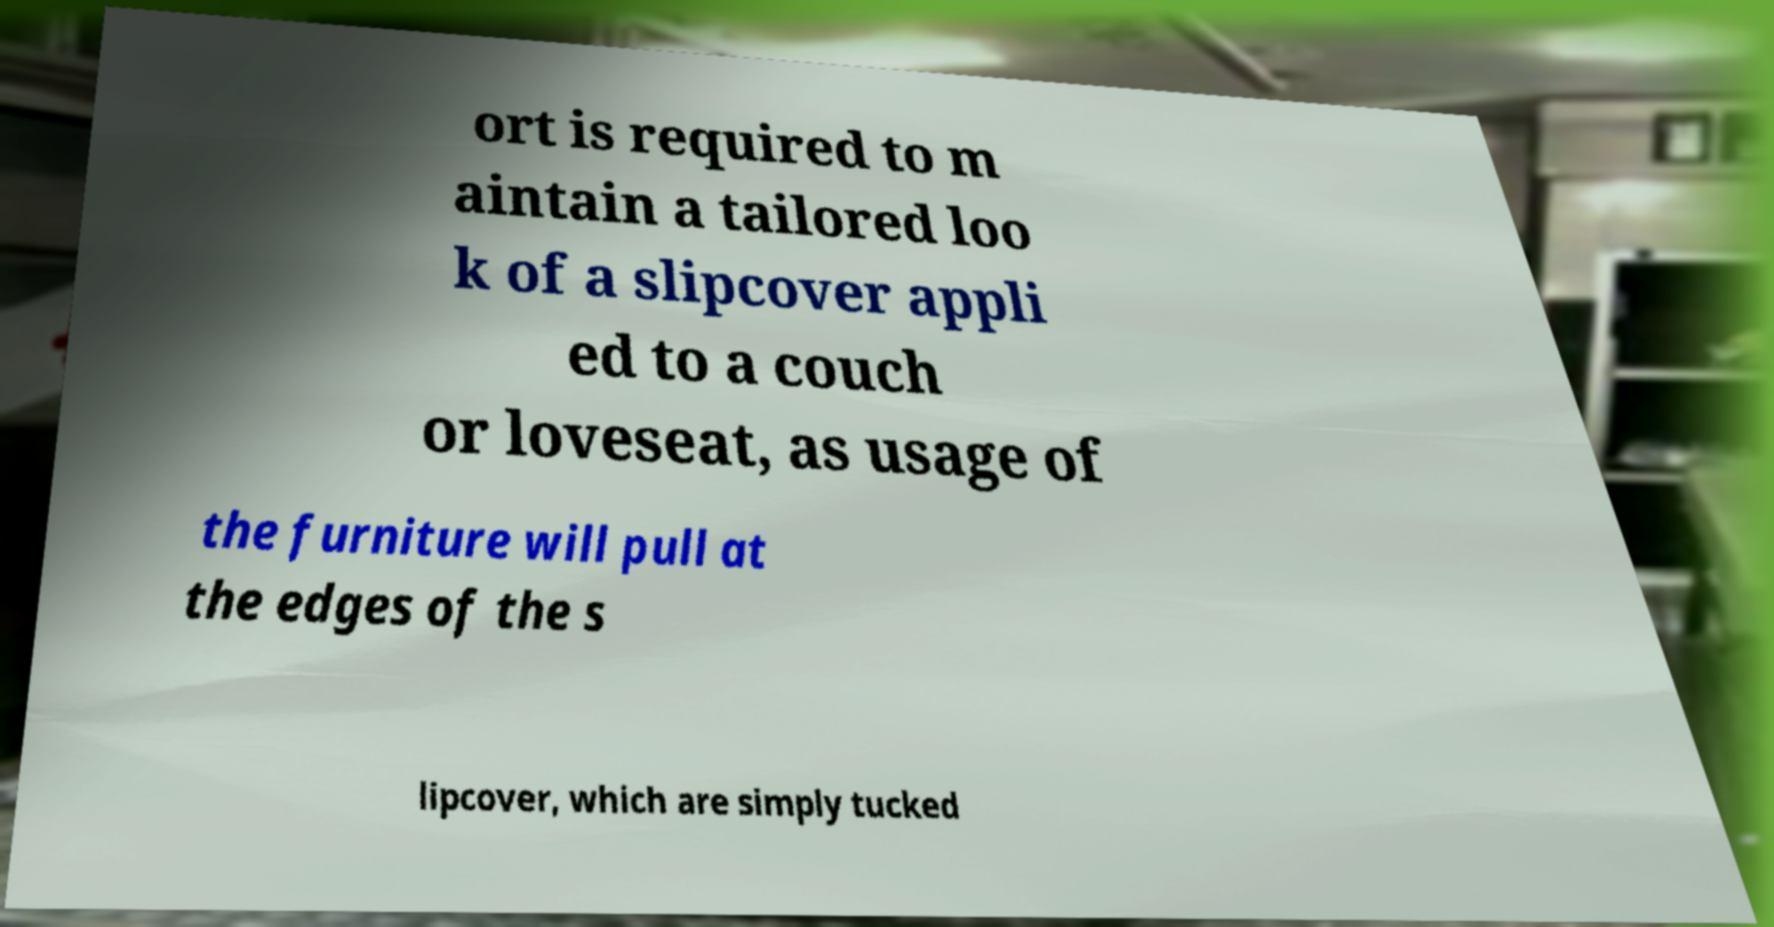Could you extract and type out the text from this image? ort is required to m aintain a tailored loo k of a slipcover appli ed to a couch or loveseat, as usage of the furniture will pull at the edges of the s lipcover, which are simply tucked 